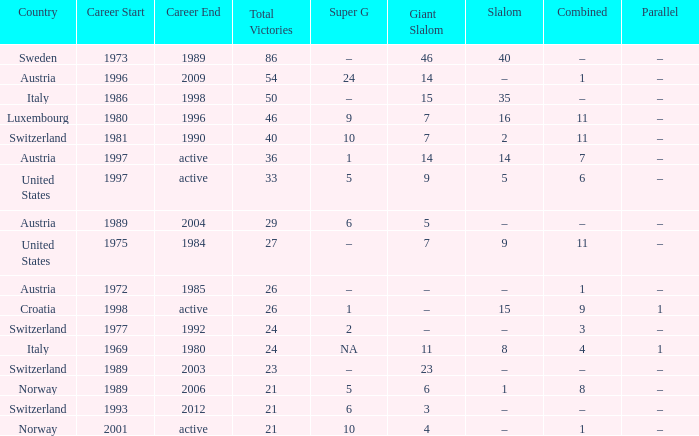What Super G has a Career of 1980–1996? 9.0. Write the full table. {'header': ['Country', 'Career Start', 'Career End', 'Total Victories', 'Super G', 'Giant Slalom', 'Slalom', 'Combined', 'Parallel'], 'rows': [['Sweden', '1973', '1989', '86', '–', '46', '40', '–', '–'], ['Austria', '1996', '2009', '54', '24', '14', '–', '1', '–'], ['Italy', '1986', '1998', '50', '–', '15', '35', '–', '–'], ['Luxembourg', '1980', '1996', '46', '9', '7', '16', '11', '–'], ['Switzerland', '1981', '1990', '40', '10', '7', '2', '11', '–'], ['Austria', '1997', 'active', '36', '1', '14', '14', '7', '–'], ['United States', '1997', 'active', '33', '5', '9', '5', '6', '–'], ['Austria', '1989', '2004', '29', '6', '5', '–', '–', '–'], ['United States', '1975', '1984', '27', '–', '7', '9', '11', '–'], ['Austria', '1972', '1985', '26', '–', '–', '–', '1', '–'], ['Croatia', '1998', 'active', '26', '1', '–', '15', '9', '1'], ['Switzerland', '1977', '1992', '24', '2', '–', '–', '3', '–'], ['Italy', '1969', '1980', '24', 'NA', '11', '8', '4', '1'], ['Switzerland', '1989', '2003', '23', '–', '23', '–', '–', '–'], ['Norway', '1989', '2006', '21', '5', '6', '1', '8', '–'], ['Switzerland', '1993', '2012', '21', '6', '3', '–', '–', '–'], ['Norway', '2001', 'active', '21', '10', '4', '–', '1', '–']]} 